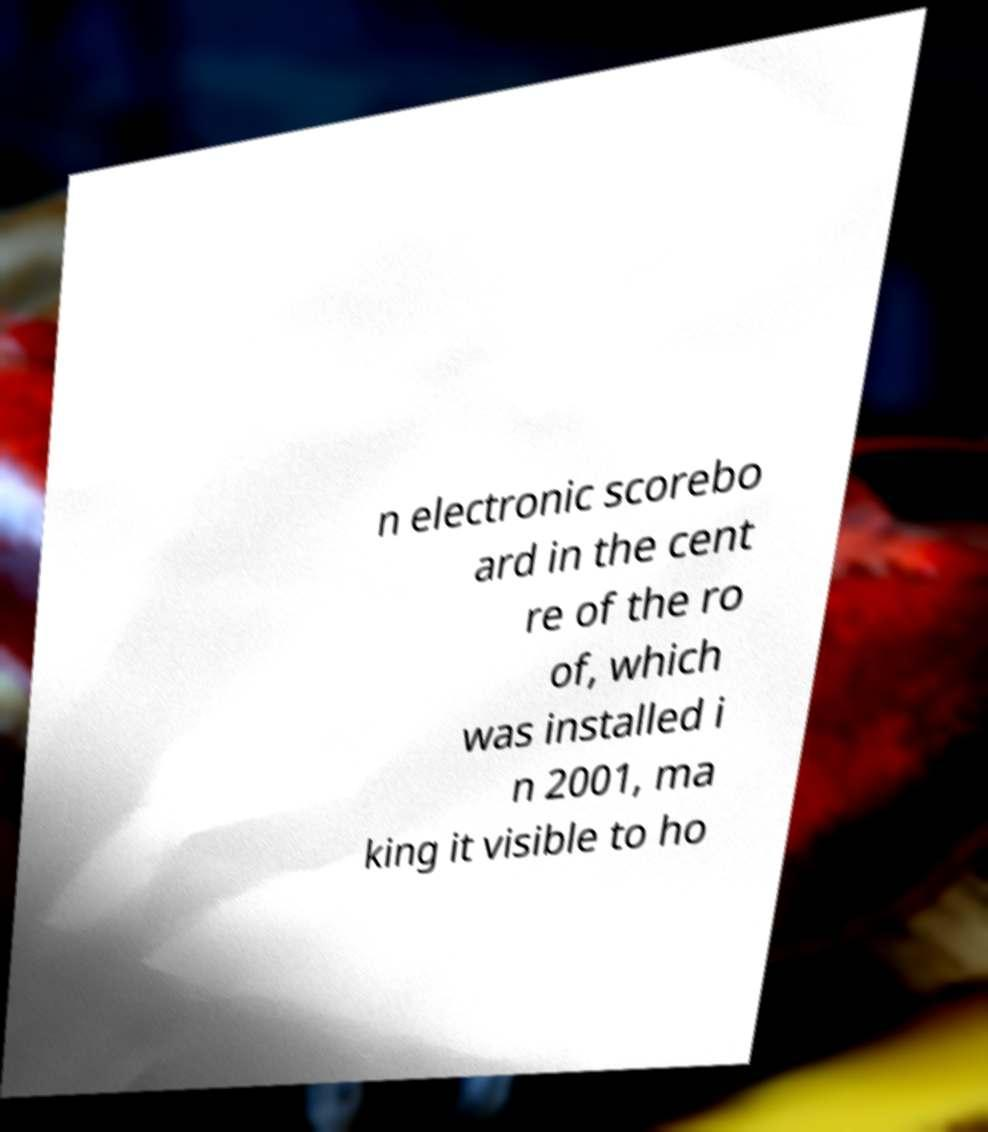What messages or text are displayed in this image? I need them in a readable, typed format. n electronic scorebo ard in the cent re of the ro of, which was installed i n 2001, ma king it visible to ho 